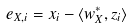<formula> <loc_0><loc_0><loc_500><loc_500>e _ { X , i } = x _ { i } - \langle w _ { X } ^ { * } , z _ { i } \rangle</formula> 